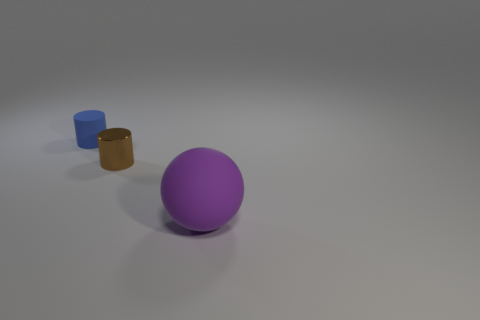What is the relative size of the objects compared to each other? The purple sphere is the largest object in the scene, with the blue cylinder being slightly smaller in height and diameter, and the brown cylinder being the smallest both in terms of height and diameter. 